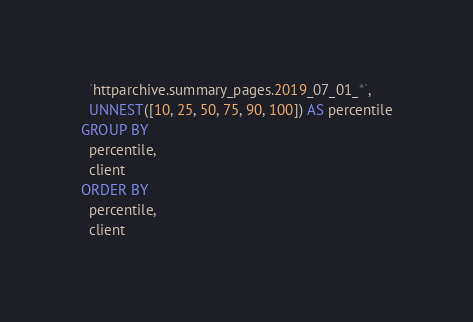Convert code to text. <code><loc_0><loc_0><loc_500><loc_500><_SQL_>  `httparchive.summary_pages.2019_07_01_*`,
  UNNEST([10, 25, 50, 75, 90, 100]) AS percentile
GROUP BY
  percentile,
  client
ORDER BY
  percentile,
  client</code> 